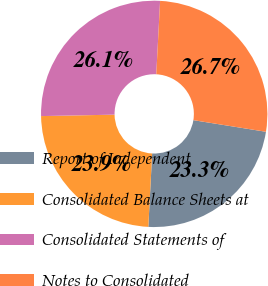<chart> <loc_0><loc_0><loc_500><loc_500><pie_chart><fcel>Report of Independent<fcel>Consolidated Balance Sheets at<fcel>Consolidated Statements of<fcel>Notes to Consolidated<nl><fcel>23.3%<fcel>23.86%<fcel>26.14%<fcel>26.7%<nl></chart> 